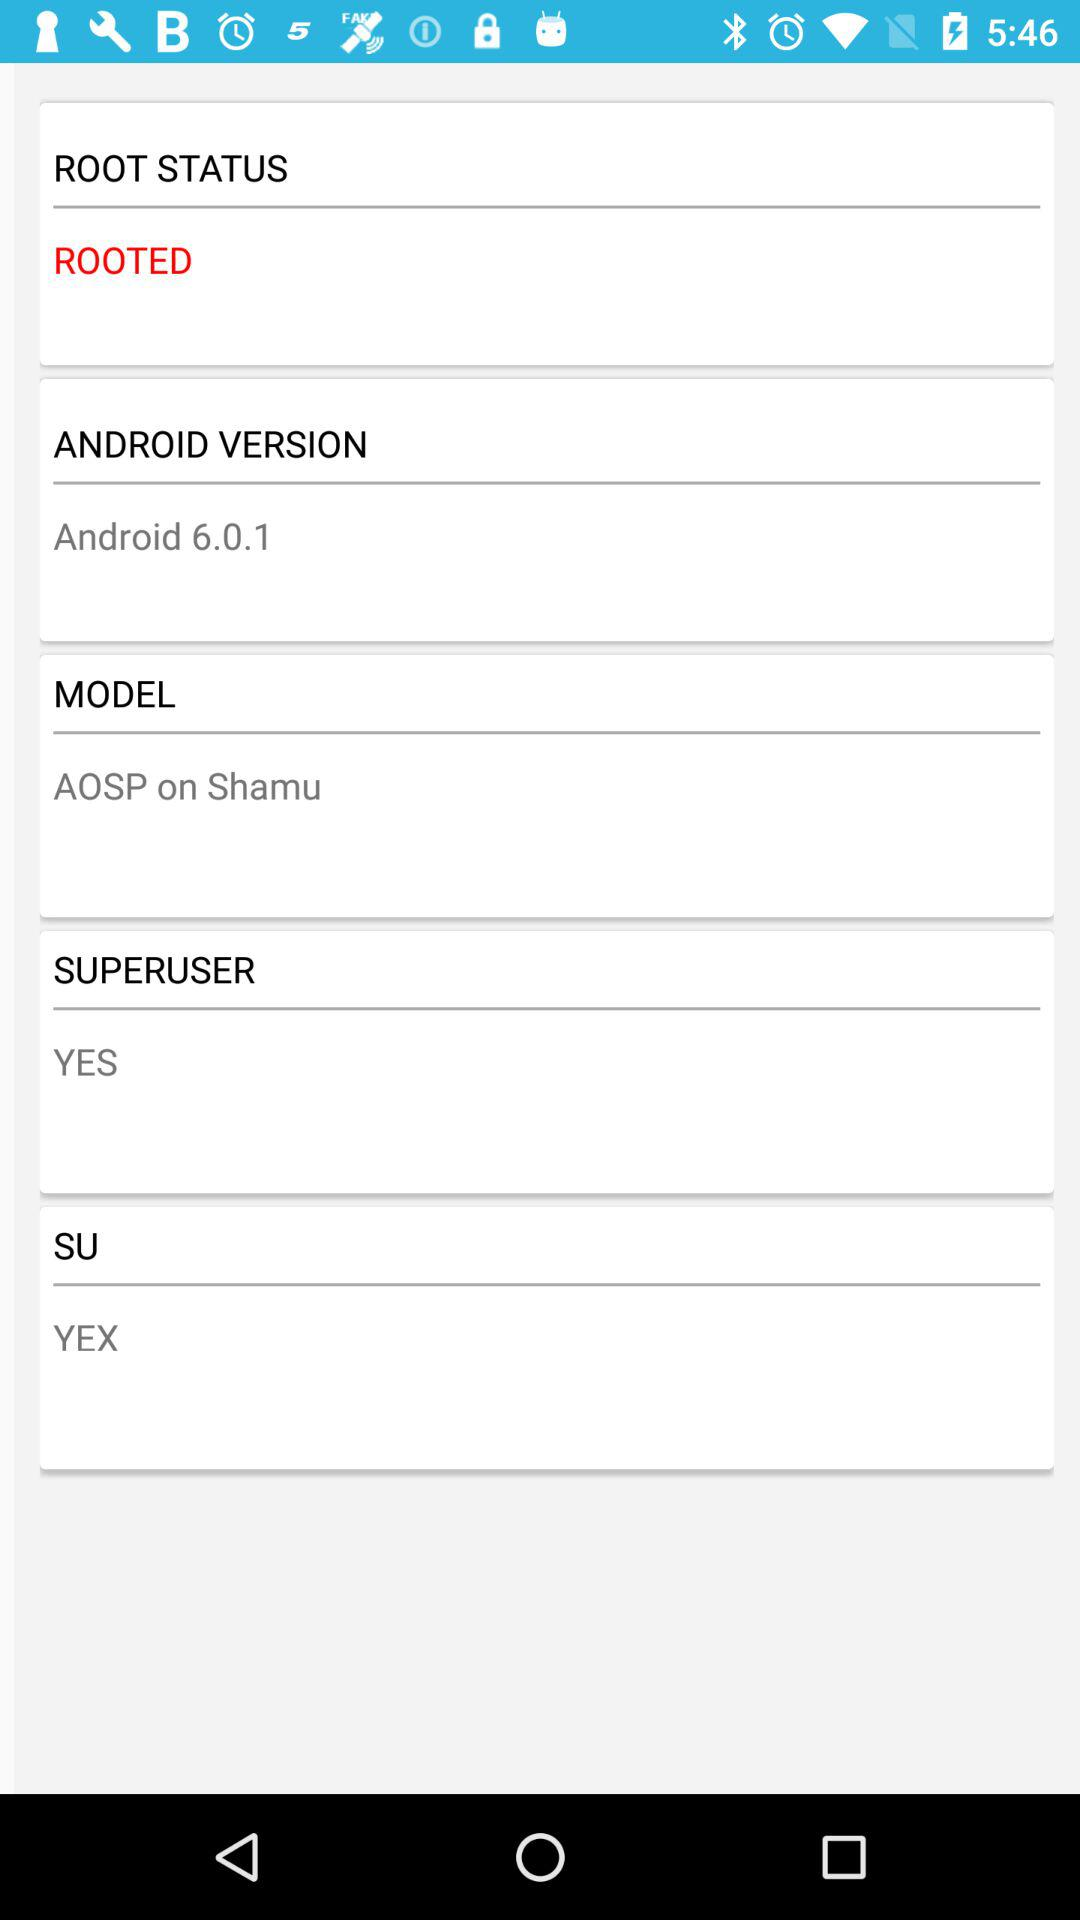Which model is it? The model is "AOSP on Shamu". 